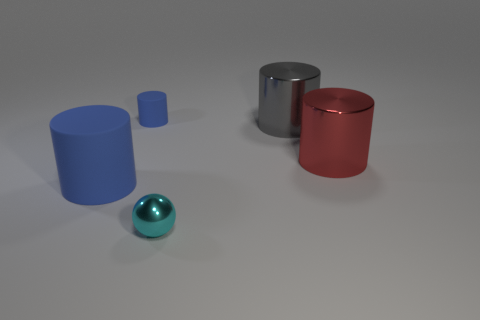Subtract 1 cylinders. How many cylinders are left? 3 Add 5 blue shiny blocks. How many objects exist? 10 Subtract all spheres. How many objects are left? 4 Subtract 1 red cylinders. How many objects are left? 4 Subtract all large blue matte cylinders. Subtract all big blue matte cylinders. How many objects are left? 3 Add 2 large gray cylinders. How many large gray cylinders are left? 3 Add 4 cylinders. How many cylinders exist? 8 